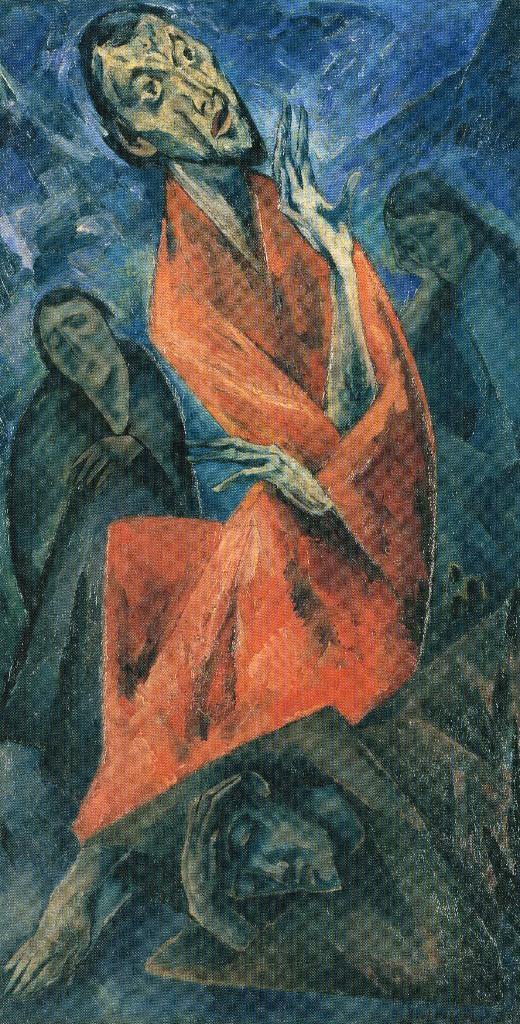Can you describe this image briefly? In this picture we can see painted board, on which we can see a image looks like a person. 